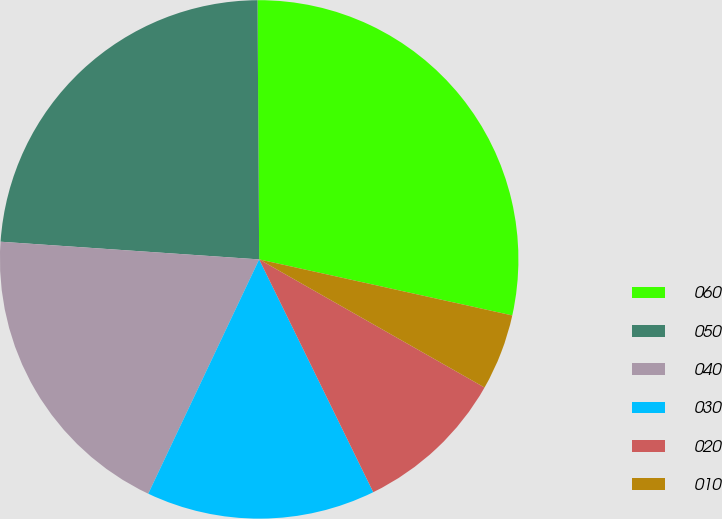Convert chart. <chart><loc_0><loc_0><loc_500><loc_500><pie_chart><fcel>060<fcel>050<fcel>040<fcel>030<fcel>020<fcel>010<nl><fcel>28.57%<fcel>23.81%<fcel>19.05%<fcel>14.29%<fcel>9.52%<fcel>4.76%<nl></chart> 